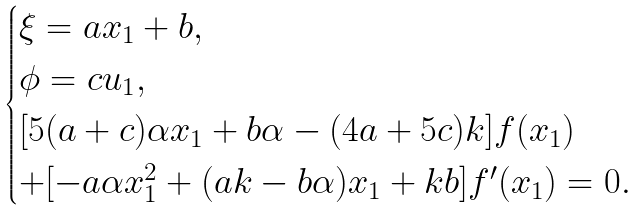<formula> <loc_0><loc_0><loc_500><loc_500>\begin{cases} \xi = a x _ { 1 } + b , \\ \phi = c u _ { 1 } , \\ [ 5 ( a + c ) \alpha x _ { 1 } + b \alpha - ( 4 a + 5 c ) k ] f ( x _ { 1 } ) \\ + [ - a \alpha x _ { 1 } ^ { 2 } + ( a k - b \alpha ) x _ { 1 } + k b ] f ^ { \prime } ( x _ { 1 } ) = 0 . \end{cases}</formula> 